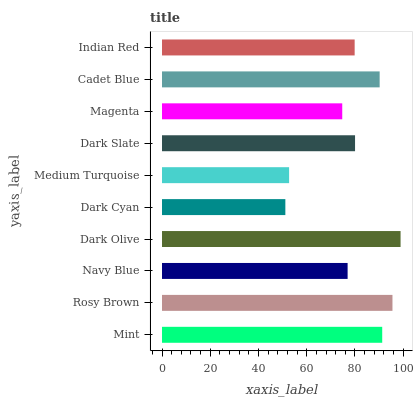Is Dark Cyan the minimum?
Answer yes or no. Yes. Is Dark Olive the maximum?
Answer yes or no. Yes. Is Rosy Brown the minimum?
Answer yes or no. No. Is Rosy Brown the maximum?
Answer yes or no. No. Is Rosy Brown greater than Mint?
Answer yes or no. Yes. Is Mint less than Rosy Brown?
Answer yes or no. Yes. Is Mint greater than Rosy Brown?
Answer yes or no. No. Is Rosy Brown less than Mint?
Answer yes or no. No. Is Dark Slate the high median?
Answer yes or no. Yes. Is Indian Red the low median?
Answer yes or no. Yes. Is Dark Olive the high median?
Answer yes or no. No. Is Navy Blue the low median?
Answer yes or no. No. 